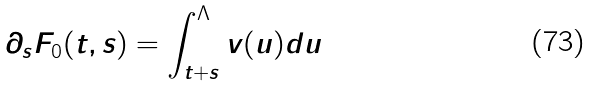<formula> <loc_0><loc_0><loc_500><loc_500>\partial _ { s } F _ { 0 } ( t , s ) = \int _ { t + s } ^ { \Lambda } v ( u ) d u</formula> 